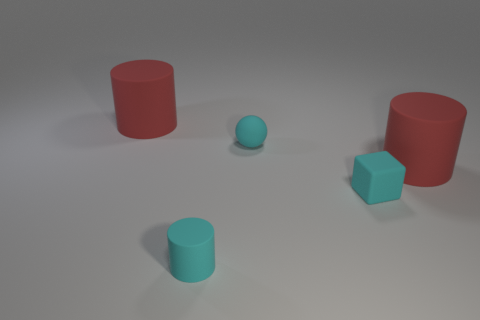What material is the big red object on the right side of the cyan rubber thing in front of the cyan matte block made of?
Provide a succinct answer. Rubber. There is a rubber block that is right of the cyan rubber sphere; what size is it?
Your answer should be compact. Small. How many cyan objects are either tiny matte objects or tiny rubber cylinders?
Your answer should be compact. 3. Is there any other thing that is the same material as the cyan cube?
Give a very brief answer. Yes. Are there the same number of tiny cyan matte spheres to the left of the small rubber cylinder and large purple spheres?
Ensure brevity in your answer.  Yes. What size is the cyan object that is on the left side of the cyan matte cube and behind the cyan matte cylinder?
Offer a terse response. Small. Is there anything else that has the same color as the small matte cylinder?
Keep it short and to the point. Yes. There is a cyan matte cylinder that is in front of the large red rubber cylinder that is on the left side of the matte ball; how big is it?
Offer a terse response. Small. There is a tiny rubber object that is in front of the cyan sphere and right of the tiny matte cylinder; what is its color?
Your answer should be compact. Cyan. How many other objects are the same size as the cyan matte block?
Provide a short and direct response. 2. 